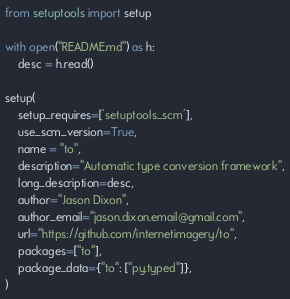<code> <loc_0><loc_0><loc_500><loc_500><_Python_>from setuptools import setup

with open("README.md") as h:
    desc = h.read()

setup(
    setup_requires=['setuptools_scm'],
    use_scm_version=True,
    name = "to",
    description="Automatic type conversion framework",
    long_description=desc,
    author="Jason Dixon",
    author_email="jason.dixon.email@gmail.com",
    url="https://github.com/internetimagery/to",
    packages=["to"],
    package_data={"to": ["py.typed"]},
)
</code> 